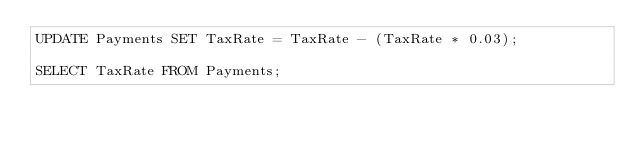<code> <loc_0><loc_0><loc_500><loc_500><_SQL_>UPDATE Payments SET TaxRate = TaxRate - (TaxRate * 0.03);

SELECT TaxRate FROM Payments;</code> 